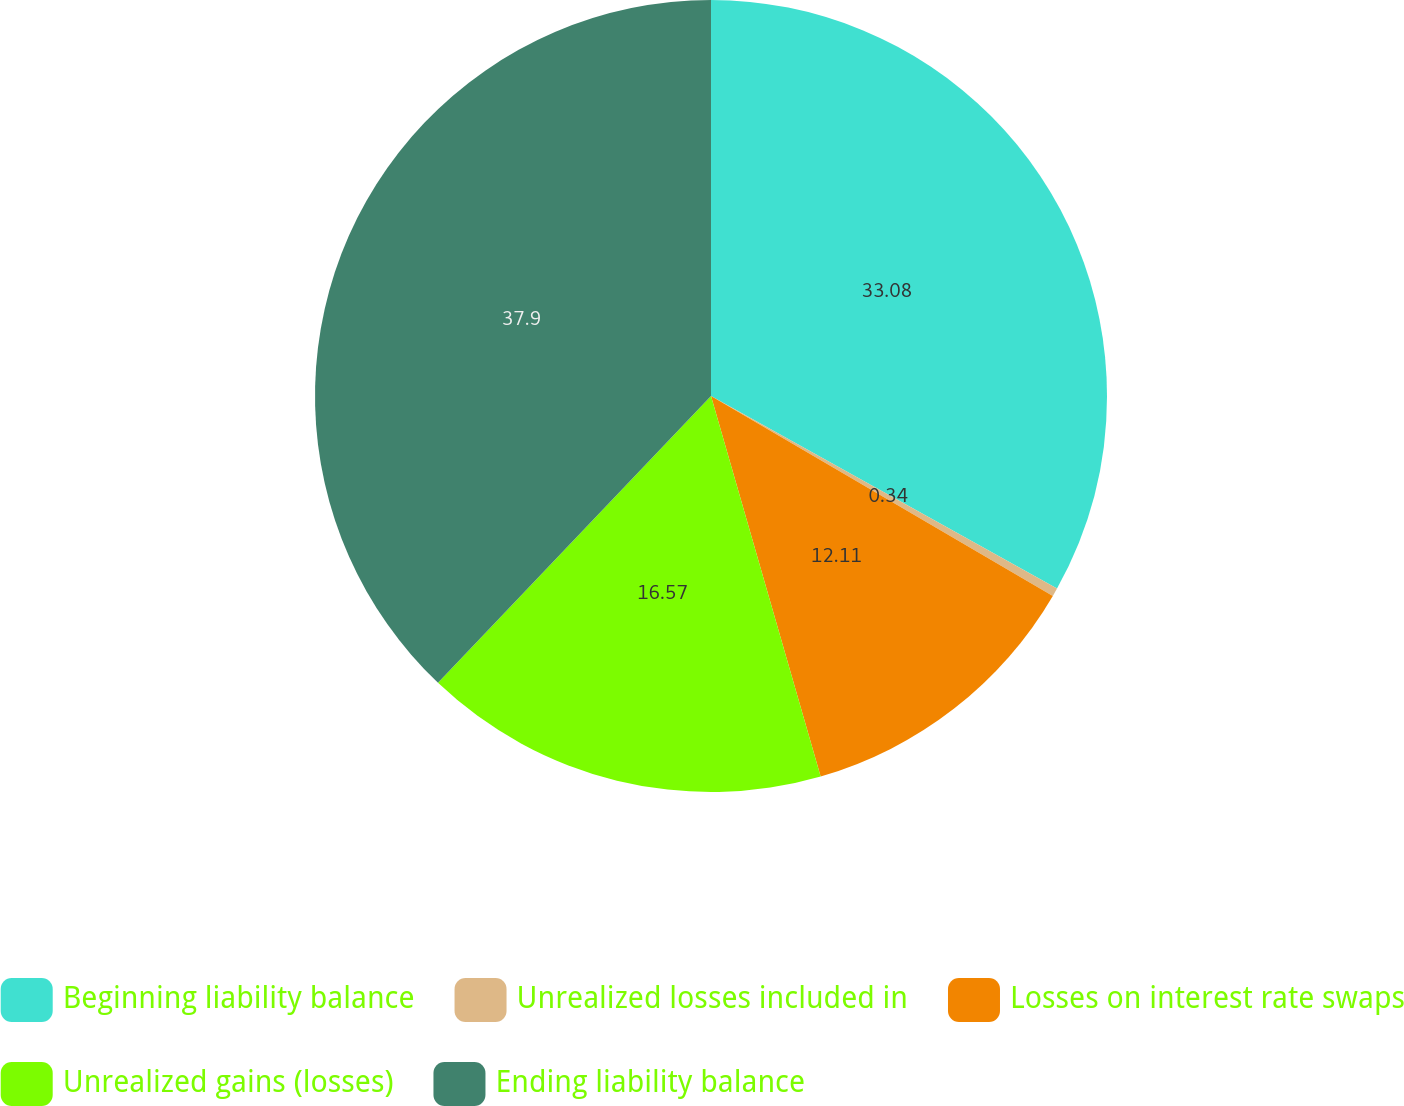Convert chart. <chart><loc_0><loc_0><loc_500><loc_500><pie_chart><fcel>Beginning liability balance<fcel>Unrealized losses included in<fcel>Losses on interest rate swaps<fcel>Unrealized gains (losses)<fcel>Ending liability balance<nl><fcel>33.08%<fcel>0.34%<fcel>12.11%<fcel>16.57%<fcel>37.89%<nl></chart> 